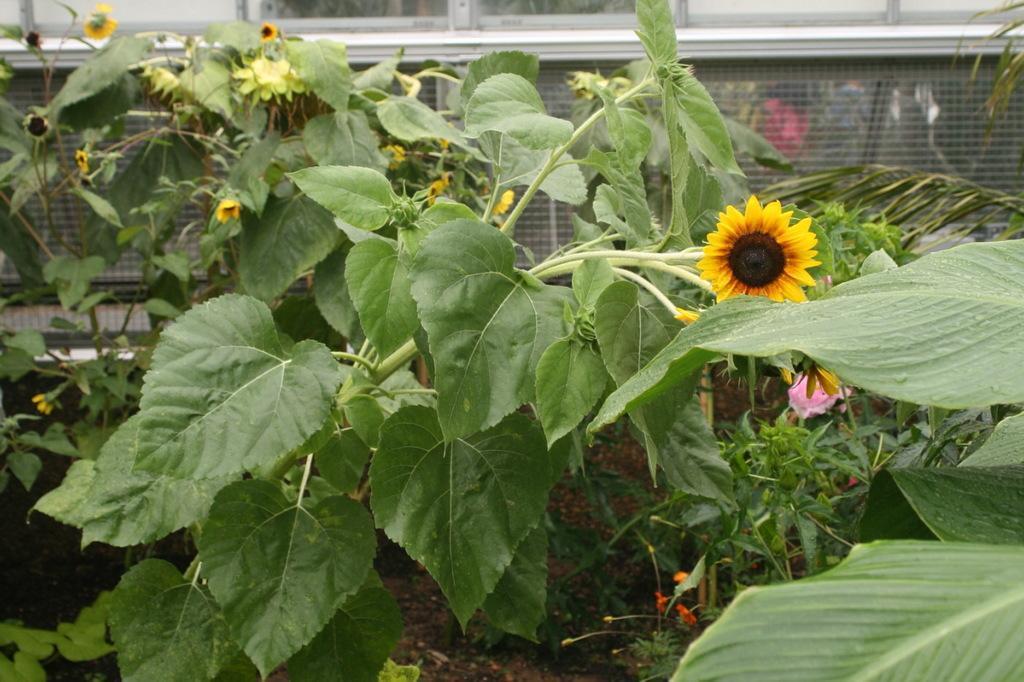Describe this image in one or two sentences. In the front of the image I can see flower plants. In the background of the image there is a mesh and windows. Through mesh I can see people. 